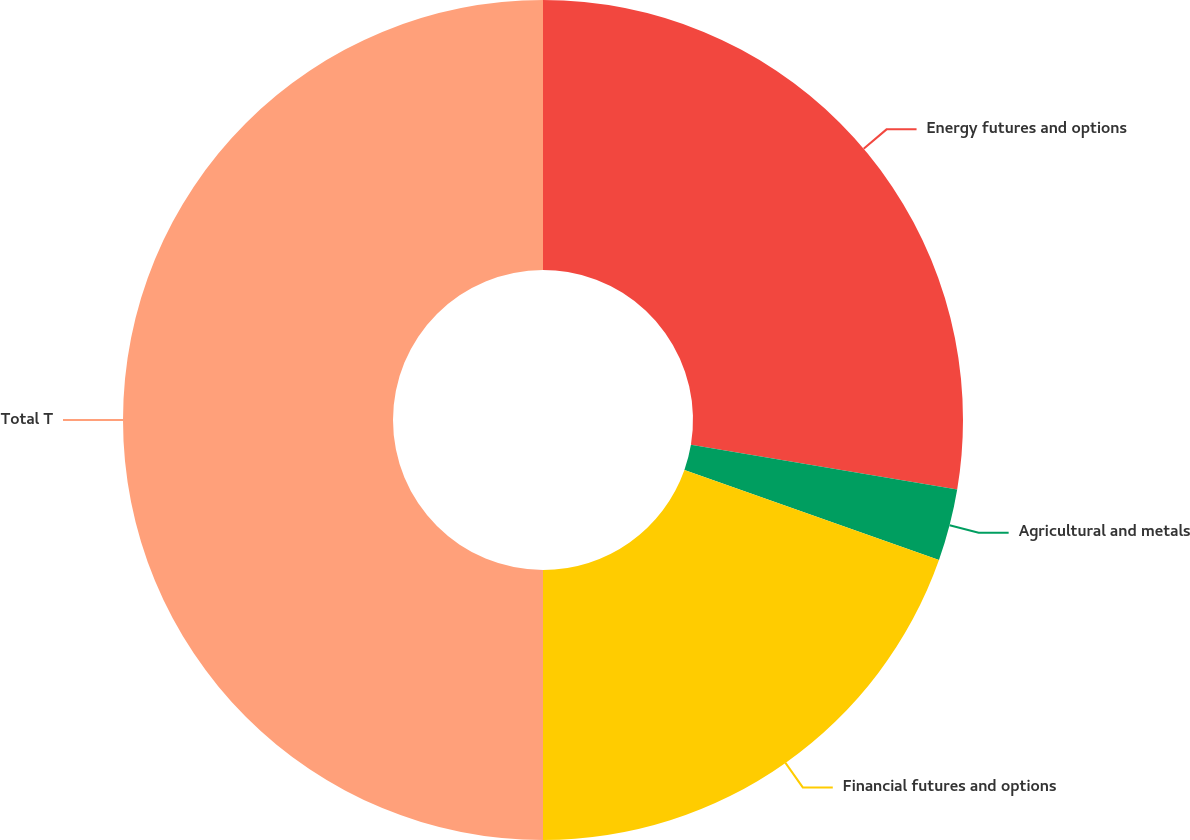<chart> <loc_0><loc_0><loc_500><loc_500><pie_chart><fcel>Energy futures and options<fcel>Agricultural and metals<fcel>Financial futures and options<fcel>Total T<nl><fcel>27.65%<fcel>2.76%<fcel>19.59%<fcel>50.0%<nl></chart> 